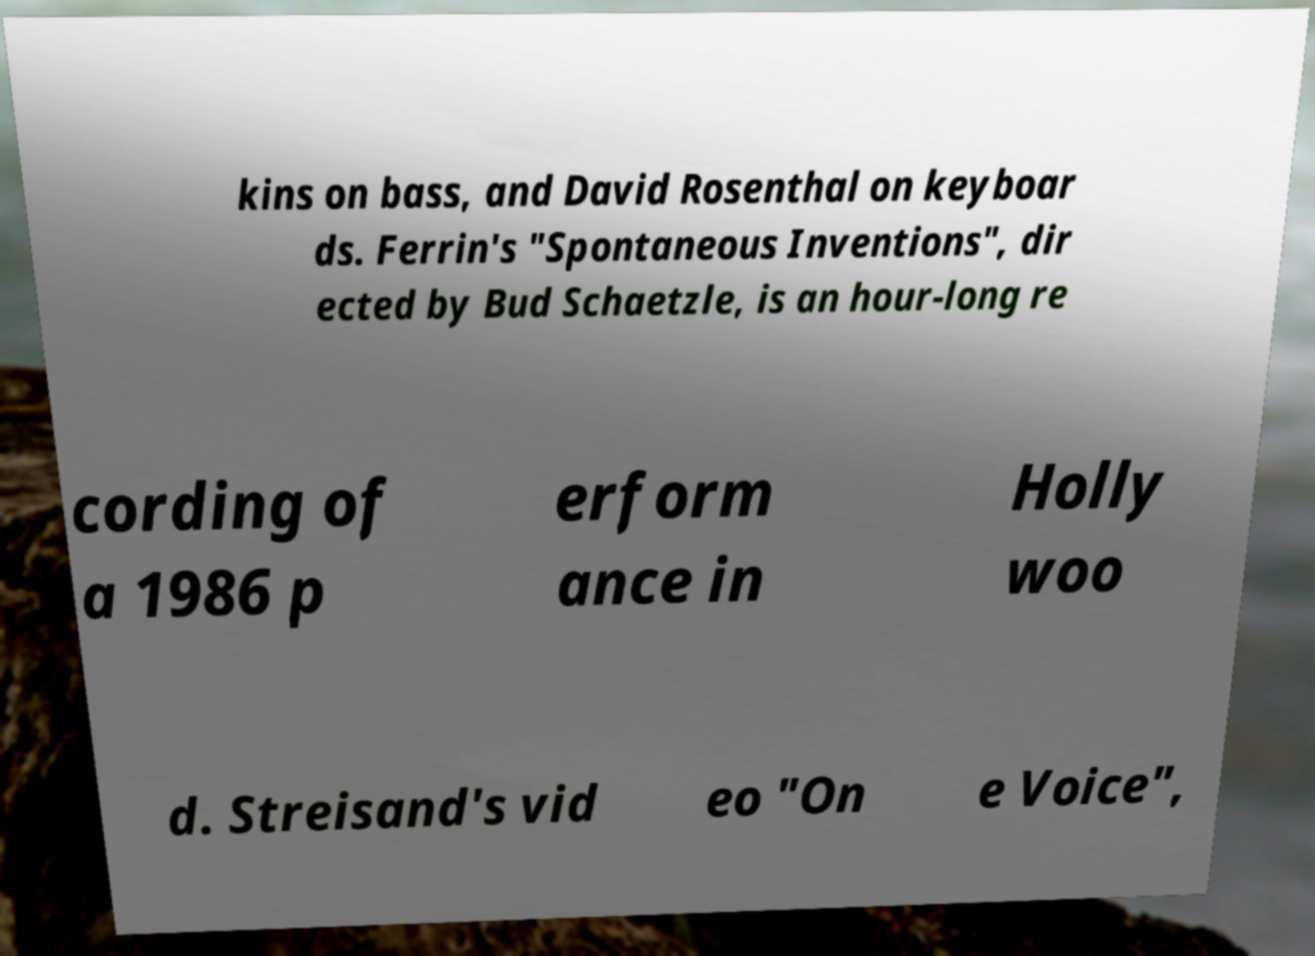Can you accurately transcribe the text from the provided image for me? kins on bass, and David Rosenthal on keyboar ds. Ferrin's "Spontaneous Inventions", dir ected by Bud Schaetzle, is an hour-long re cording of a 1986 p erform ance in Holly woo d. Streisand's vid eo "On e Voice", 